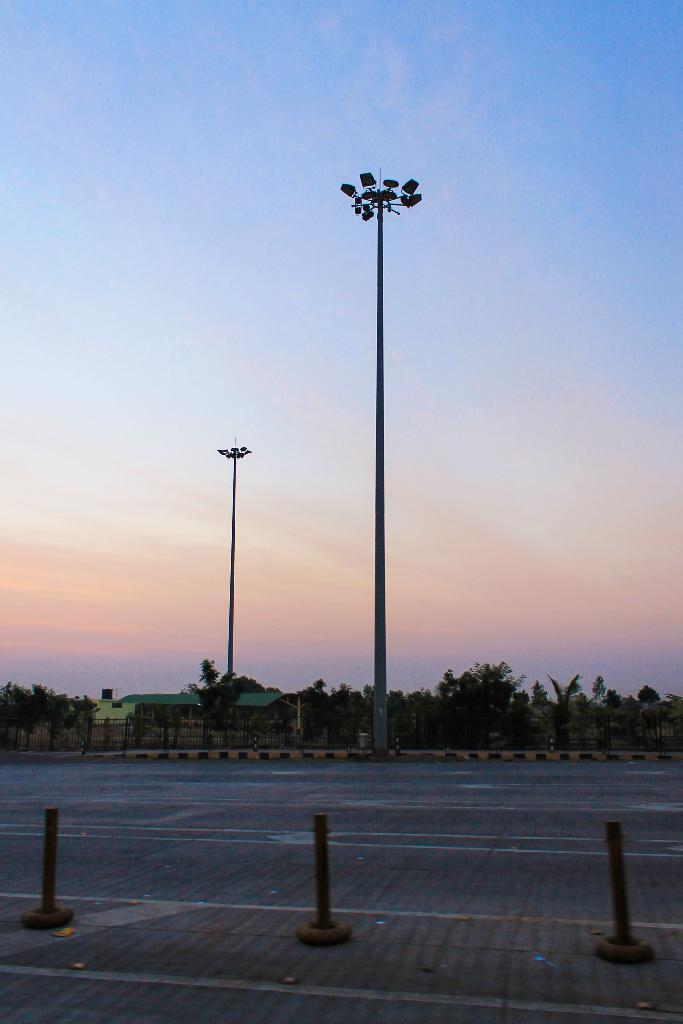What structures can be seen in the image? There are poles, a fence, street lights, and houses in the image. What type of vegetation is present in the image? There are trees in the image. What part of the natural environment is visible in the image? The sky is visible in the image. What is the likely setting of the image? The image is likely taken on a road. What advertisement can be seen on the trees in the image? There are no advertisements present on the trees in the image. What time of day is it in the image, considering the presence of street lights? The presence of street lights does not necessarily indicate the time of day, as they can be used for various purposes, including illuminating the area at night or during the day for safety reasons. 